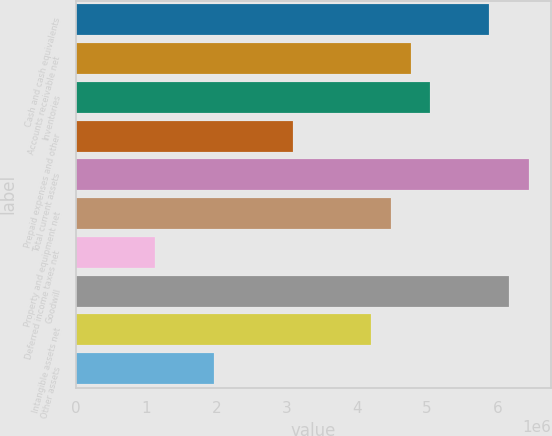Convert chart. <chart><loc_0><loc_0><loc_500><loc_500><bar_chart><fcel>Cash and cash equivalents<fcel>Accounts receivable net<fcel>Inventories<fcel>Prepaid expenses and other<fcel>Total current assets<fcel>Property and equipment net<fcel>Deferred income taxes net<fcel>Goodwill<fcel>Intangible assets net<fcel>Other assets<nl><fcel>5.88731e+06<fcel>4.7683e+06<fcel>5.04805e+06<fcel>3.08978e+06<fcel>6.44682e+06<fcel>4.48854e+06<fcel>1.13151e+06<fcel>6.16706e+06<fcel>4.20879e+06<fcel>1.97077e+06<nl></chart> 